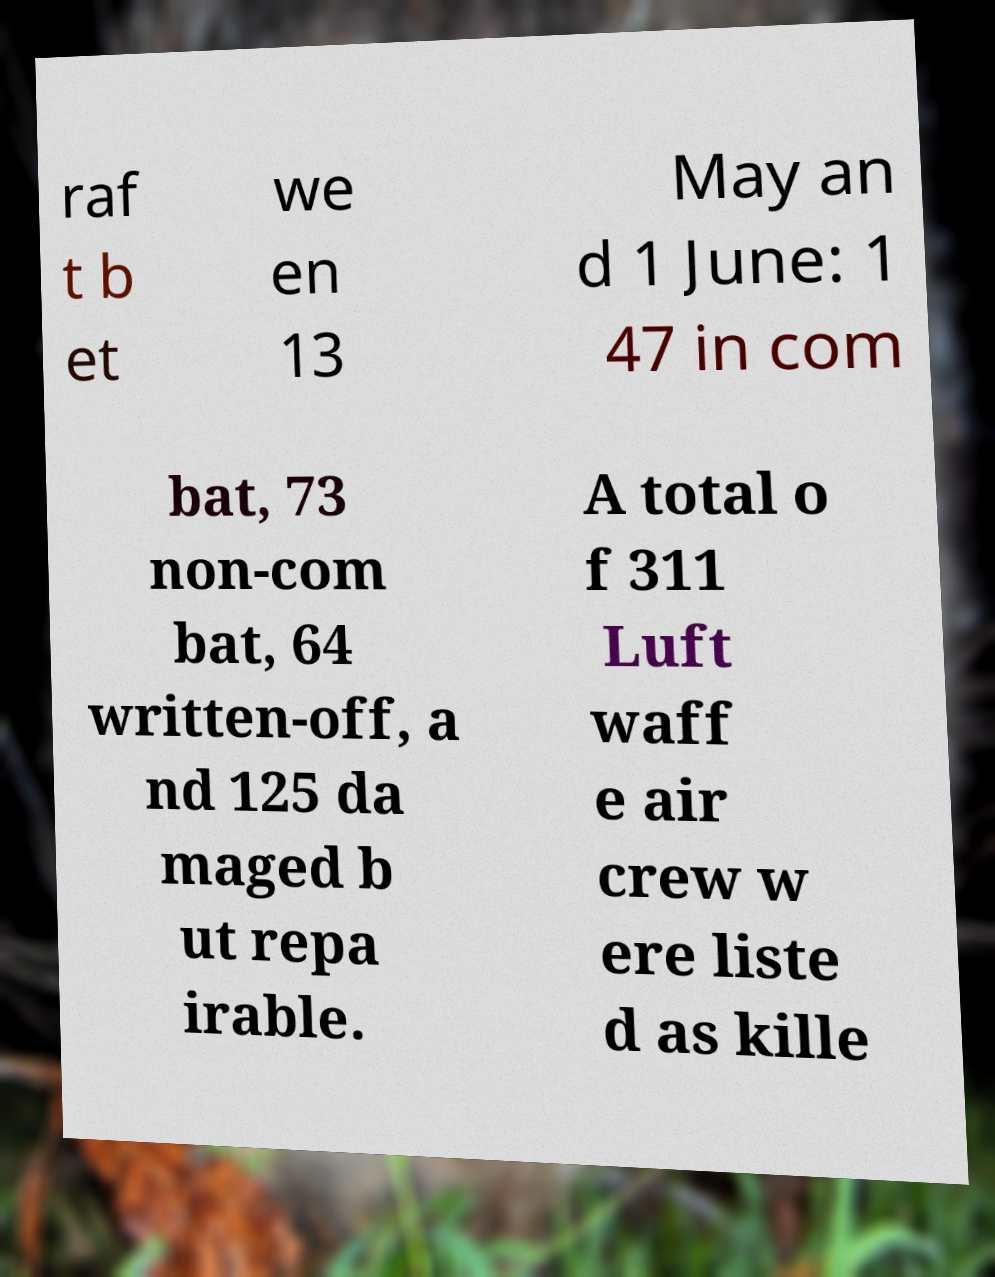Could you assist in decoding the text presented in this image and type it out clearly? raf t b et we en 13 May an d 1 June: 1 47 in com bat, 73 non-com bat, 64 written-off, a nd 125 da maged b ut repa irable. A total o f 311 Luft waff e air crew w ere liste d as kille 